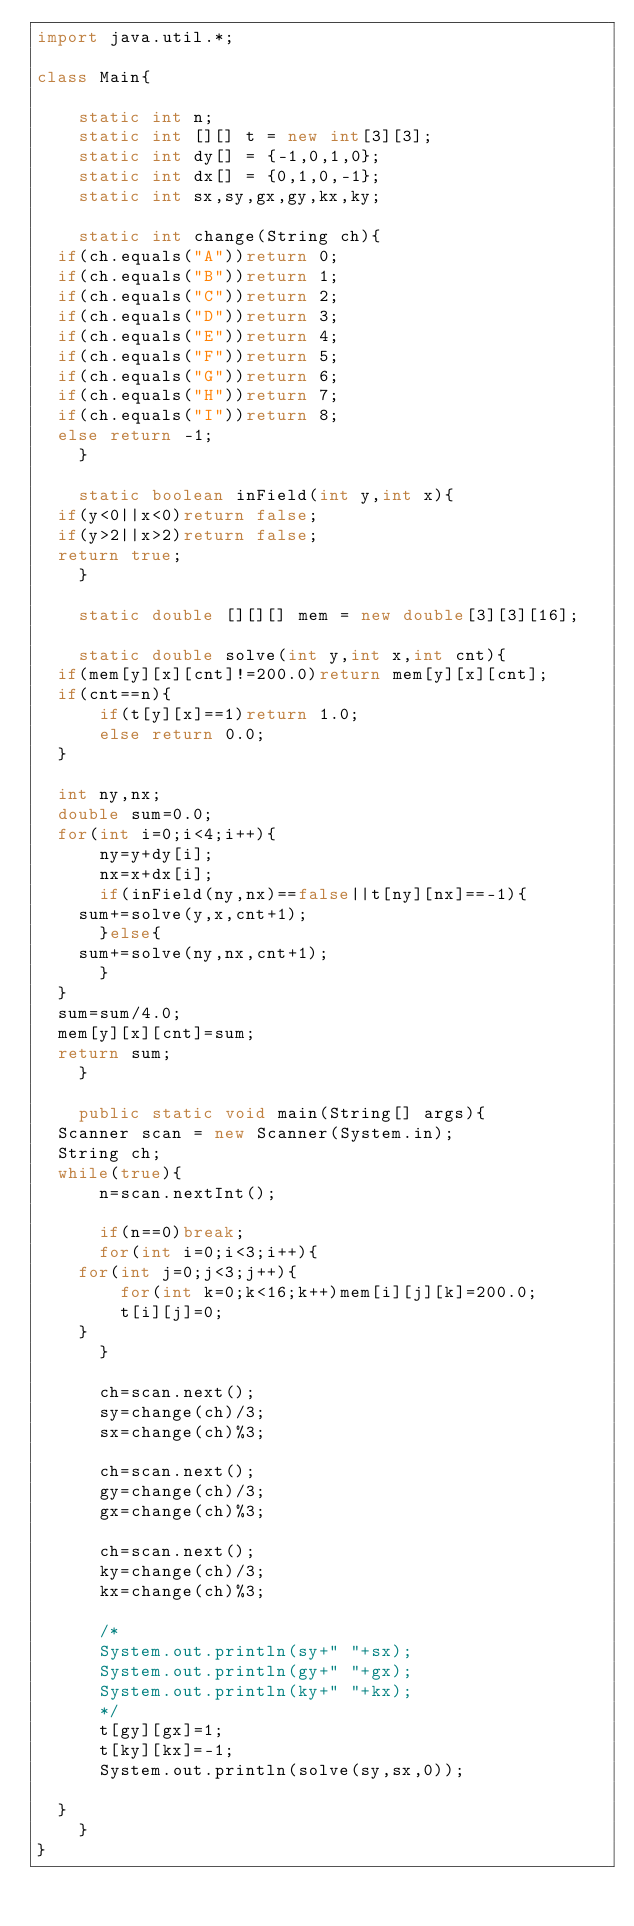Convert code to text. <code><loc_0><loc_0><loc_500><loc_500><_Java_>import java.util.*;

class Main{

    static int n;
    static int [][] t = new int[3][3];
    static int dy[] = {-1,0,1,0};
    static int dx[] = {0,1,0,-1};
    static int sx,sy,gx,gy,kx,ky;

    static int change(String ch){
	if(ch.equals("A"))return 0;
	if(ch.equals("B"))return 1;
	if(ch.equals("C"))return 2;
	if(ch.equals("D"))return 3;
	if(ch.equals("E"))return 4;
	if(ch.equals("F"))return 5;
	if(ch.equals("G"))return 6;
	if(ch.equals("H"))return 7;
	if(ch.equals("I"))return 8;
	else return -1;
    }

    static boolean inField(int y,int x){
	if(y<0||x<0)return false;
	if(y>2||x>2)return false;
	return true;
    }
    
    static double [][][] mem = new double[3][3][16];

    static double solve(int y,int x,int cnt){
	if(mem[y][x][cnt]!=200.0)return mem[y][x][cnt];
	if(cnt==n){
	    if(t[y][x]==1)return 1.0;
	    else return 0.0;
	}
	
	int ny,nx;
	double sum=0.0;
	for(int i=0;i<4;i++){
	    ny=y+dy[i];
	    nx=x+dx[i];
	    if(inField(ny,nx)==false||t[ny][nx]==-1){
		sum+=solve(y,x,cnt+1);
	    }else{
		sum+=solve(ny,nx,cnt+1);
	    }
	}
	sum=sum/4.0;
	mem[y][x][cnt]=sum;
	return sum;
    }

    public static void main(String[] args){
	Scanner scan = new Scanner(System.in);
	String ch;
	while(true){
	    n=scan.nextInt();

	    if(n==0)break;
	    for(int i=0;i<3;i++){
		for(int j=0;j<3;j++){
		    for(int k=0;k<16;k++)mem[i][j][k]=200.0;
		    t[i][j]=0;
		}
	    }

	    ch=scan.next();
	    sy=change(ch)/3;
	    sx=change(ch)%3;

	    ch=scan.next();
	    gy=change(ch)/3;
	    gx=change(ch)%3;

	    ch=scan.next();
	    ky=change(ch)/3;
	    kx=change(ch)%3;

	    /*
	    System.out.println(sy+" "+sx);
	    System.out.println(gy+" "+gx);
	    System.out.println(ky+" "+kx);
	    */
	    t[gy][gx]=1;
	    t[ky][kx]=-1;
	    System.out.println(solve(sy,sx,0));

	}
    }
}</code> 